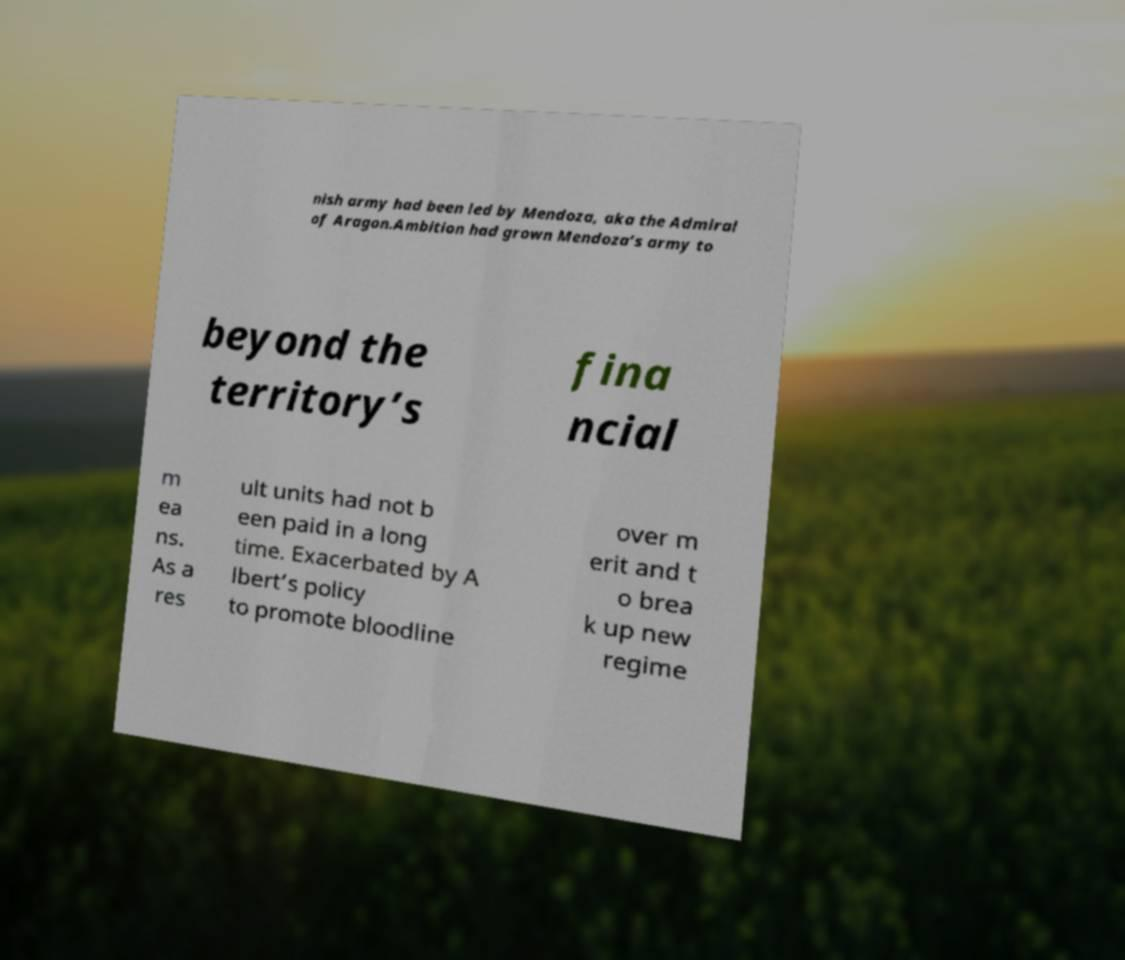For documentation purposes, I need the text within this image transcribed. Could you provide that? nish army had been led by Mendoza, aka the Admiral of Aragon.Ambition had grown Mendoza’s army to beyond the territory’s fina ncial m ea ns. As a res ult units had not b een paid in a long time. Exacerbated by A lbert’s policy to promote bloodline over m erit and t o brea k up new regime 